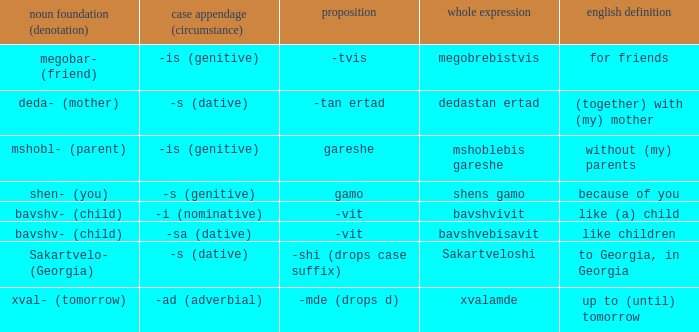What is the Full Word, when Case Suffix (case) is "-sa (dative)"? Bavshvebisavit. 